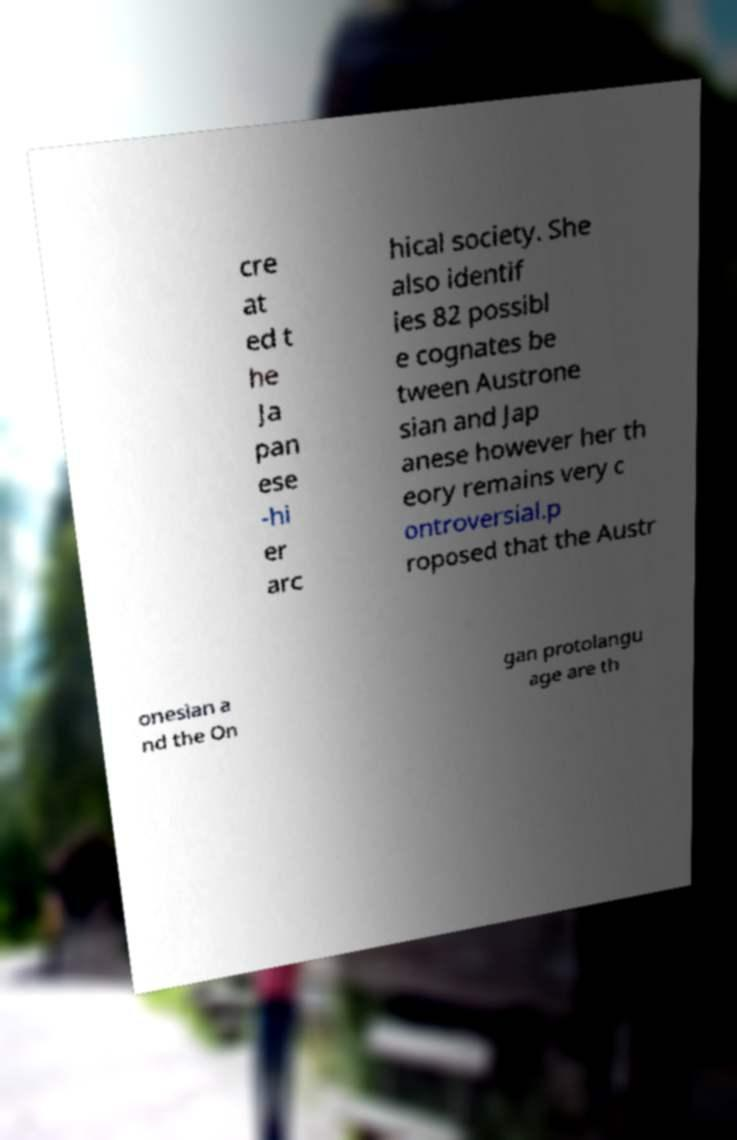Can you read and provide the text displayed in the image?This photo seems to have some interesting text. Can you extract and type it out for me? cre at ed t he Ja pan ese -hi er arc hical society. She also identif ies 82 possibl e cognates be tween Austrone sian and Jap anese however her th eory remains very c ontroversial.p roposed that the Austr onesian a nd the On gan protolangu age are th 